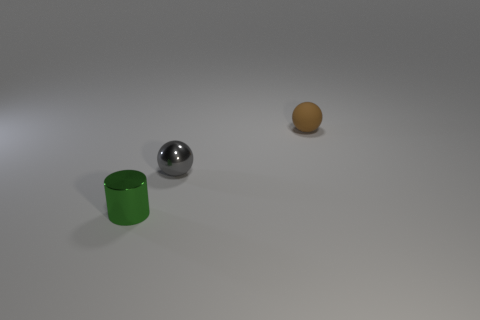Add 3 big gray metal cylinders. How many objects exist? 6 Subtract 2 spheres. How many spheres are left? 0 Subtract all brown spheres. How many spheres are left? 1 Subtract all cylinders. How many objects are left? 2 Subtract all small green metal things. Subtract all purple shiny things. How many objects are left? 2 Add 2 spheres. How many spheres are left? 4 Add 2 small green objects. How many small green objects exist? 3 Subtract 0 blue cylinders. How many objects are left? 3 Subtract all purple balls. Subtract all yellow cylinders. How many balls are left? 2 Subtract all purple cubes. How many gray balls are left? 1 